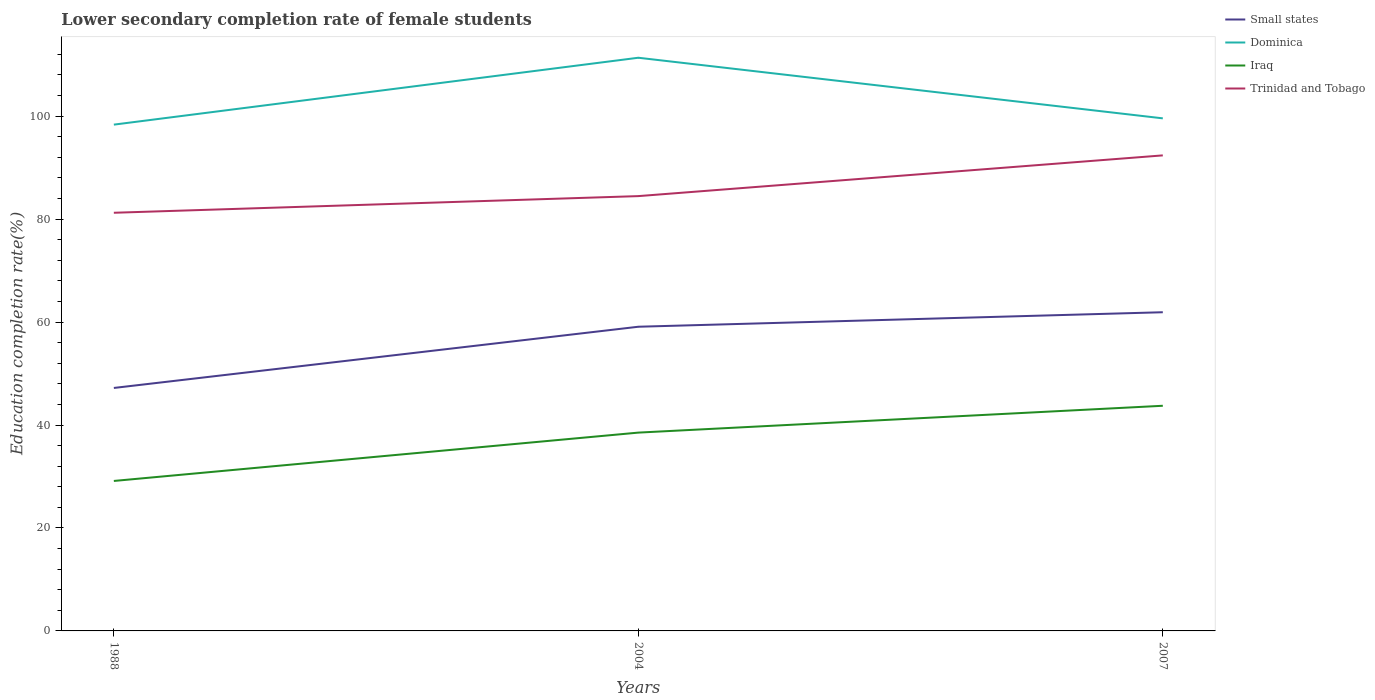How many different coloured lines are there?
Provide a short and direct response. 4. Is the number of lines equal to the number of legend labels?
Your response must be concise. Yes. Across all years, what is the maximum lower secondary completion rate of female students in Small states?
Provide a succinct answer. 47.2. In which year was the lower secondary completion rate of female students in Iraq maximum?
Offer a terse response. 1988. What is the total lower secondary completion rate of female students in Dominica in the graph?
Ensure brevity in your answer.  11.78. What is the difference between the highest and the second highest lower secondary completion rate of female students in Dominica?
Keep it short and to the point. 13. Is the lower secondary completion rate of female students in Iraq strictly greater than the lower secondary completion rate of female students in Trinidad and Tobago over the years?
Your response must be concise. Yes. What is the difference between two consecutive major ticks on the Y-axis?
Your answer should be compact. 20. Are the values on the major ticks of Y-axis written in scientific E-notation?
Offer a terse response. No. Does the graph contain any zero values?
Your answer should be compact. No. Does the graph contain grids?
Keep it short and to the point. No. Where does the legend appear in the graph?
Provide a short and direct response. Top right. How many legend labels are there?
Your response must be concise. 4. What is the title of the graph?
Offer a very short reply. Lower secondary completion rate of female students. What is the label or title of the X-axis?
Your answer should be very brief. Years. What is the label or title of the Y-axis?
Offer a very short reply. Education completion rate(%). What is the Education completion rate(%) in Small states in 1988?
Make the answer very short. 47.2. What is the Education completion rate(%) in Dominica in 1988?
Make the answer very short. 98.36. What is the Education completion rate(%) of Iraq in 1988?
Provide a succinct answer. 29.13. What is the Education completion rate(%) of Trinidad and Tobago in 1988?
Your answer should be very brief. 81.24. What is the Education completion rate(%) of Small states in 2004?
Give a very brief answer. 59.09. What is the Education completion rate(%) of Dominica in 2004?
Provide a short and direct response. 111.35. What is the Education completion rate(%) of Iraq in 2004?
Provide a succinct answer. 38.53. What is the Education completion rate(%) in Trinidad and Tobago in 2004?
Your response must be concise. 84.47. What is the Education completion rate(%) of Small states in 2007?
Your answer should be very brief. 61.91. What is the Education completion rate(%) of Dominica in 2007?
Offer a very short reply. 99.58. What is the Education completion rate(%) in Iraq in 2007?
Provide a succinct answer. 43.74. What is the Education completion rate(%) of Trinidad and Tobago in 2007?
Provide a short and direct response. 92.38. Across all years, what is the maximum Education completion rate(%) of Small states?
Provide a succinct answer. 61.91. Across all years, what is the maximum Education completion rate(%) of Dominica?
Provide a short and direct response. 111.35. Across all years, what is the maximum Education completion rate(%) in Iraq?
Offer a very short reply. 43.74. Across all years, what is the maximum Education completion rate(%) of Trinidad and Tobago?
Provide a short and direct response. 92.38. Across all years, what is the minimum Education completion rate(%) in Small states?
Offer a terse response. 47.2. Across all years, what is the minimum Education completion rate(%) in Dominica?
Offer a terse response. 98.36. Across all years, what is the minimum Education completion rate(%) in Iraq?
Keep it short and to the point. 29.13. Across all years, what is the minimum Education completion rate(%) in Trinidad and Tobago?
Make the answer very short. 81.24. What is the total Education completion rate(%) of Small states in the graph?
Your answer should be very brief. 168.21. What is the total Education completion rate(%) in Dominica in the graph?
Ensure brevity in your answer.  309.29. What is the total Education completion rate(%) in Iraq in the graph?
Keep it short and to the point. 111.4. What is the total Education completion rate(%) of Trinidad and Tobago in the graph?
Keep it short and to the point. 258.09. What is the difference between the Education completion rate(%) of Small states in 1988 and that in 2004?
Ensure brevity in your answer.  -11.89. What is the difference between the Education completion rate(%) of Dominica in 1988 and that in 2004?
Keep it short and to the point. -13. What is the difference between the Education completion rate(%) in Iraq in 1988 and that in 2004?
Your answer should be very brief. -9.39. What is the difference between the Education completion rate(%) in Trinidad and Tobago in 1988 and that in 2004?
Your answer should be very brief. -3.24. What is the difference between the Education completion rate(%) in Small states in 1988 and that in 2007?
Your response must be concise. -14.71. What is the difference between the Education completion rate(%) in Dominica in 1988 and that in 2007?
Provide a succinct answer. -1.22. What is the difference between the Education completion rate(%) of Iraq in 1988 and that in 2007?
Ensure brevity in your answer.  -14.61. What is the difference between the Education completion rate(%) of Trinidad and Tobago in 1988 and that in 2007?
Provide a short and direct response. -11.15. What is the difference between the Education completion rate(%) of Small states in 2004 and that in 2007?
Your answer should be very brief. -2.82. What is the difference between the Education completion rate(%) in Dominica in 2004 and that in 2007?
Provide a short and direct response. 11.78. What is the difference between the Education completion rate(%) in Iraq in 2004 and that in 2007?
Provide a short and direct response. -5.22. What is the difference between the Education completion rate(%) of Trinidad and Tobago in 2004 and that in 2007?
Give a very brief answer. -7.91. What is the difference between the Education completion rate(%) in Small states in 1988 and the Education completion rate(%) in Dominica in 2004?
Give a very brief answer. -64.15. What is the difference between the Education completion rate(%) of Small states in 1988 and the Education completion rate(%) of Iraq in 2004?
Your answer should be very brief. 8.67. What is the difference between the Education completion rate(%) in Small states in 1988 and the Education completion rate(%) in Trinidad and Tobago in 2004?
Provide a short and direct response. -37.27. What is the difference between the Education completion rate(%) in Dominica in 1988 and the Education completion rate(%) in Iraq in 2004?
Make the answer very short. 59.83. What is the difference between the Education completion rate(%) of Dominica in 1988 and the Education completion rate(%) of Trinidad and Tobago in 2004?
Keep it short and to the point. 13.89. What is the difference between the Education completion rate(%) of Iraq in 1988 and the Education completion rate(%) of Trinidad and Tobago in 2004?
Provide a succinct answer. -55.34. What is the difference between the Education completion rate(%) in Small states in 1988 and the Education completion rate(%) in Dominica in 2007?
Keep it short and to the point. -52.37. What is the difference between the Education completion rate(%) of Small states in 1988 and the Education completion rate(%) of Iraq in 2007?
Give a very brief answer. 3.46. What is the difference between the Education completion rate(%) in Small states in 1988 and the Education completion rate(%) in Trinidad and Tobago in 2007?
Give a very brief answer. -45.18. What is the difference between the Education completion rate(%) of Dominica in 1988 and the Education completion rate(%) of Iraq in 2007?
Your answer should be compact. 54.61. What is the difference between the Education completion rate(%) of Dominica in 1988 and the Education completion rate(%) of Trinidad and Tobago in 2007?
Offer a very short reply. 5.97. What is the difference between the Education completion rate(%) in Iraq in 1988 and the Education completion rate(%) in Trinidad and Tobago in 2007?
Offer a very short reply. -63.25. What is the difference between the Education completion rate(%) in Small states in 2004 and the Education completion rate(%) in Dominica in 2007?
Your response must be concise. -40.48. What is the difference between the Education completion rate(%) in Small states in 2004 and the Education completion rate(%) in Iraq in 2007?
Provide a succinct answer. 15.35. What is the difference between the Education completion rate(%) in Small states in 2004 and the Education completion rate(%) in Trinidad and Tobago in 2007?
Provide a succinct answer. -33.29. What is the difference between the Education completion rate(%) of Dominica in 2004 and the Education completion rate(%) of Iraq in 2007?
Ensure brevity in your answer.  67.61. What is the difference between the Education completion rate(%) of Dominica in 2004 and the Education completion rate(%) of Trinidad and Tobago in 2007?
Keep it short and to the point. 18.97. What is the difference between the Education completion rate(%) of Iraq in 2004 and the Education completion rate(%) of Trinidad and Tobago in 2007?
Give a very brief answer. -53.86. What is the average Education completion rate(%) in Small states per year?
Offer a terse response. 56.07. What is the average Education completion rate(%) of Dominica per year?
Offer a very short reply. 103.1. What is the average Education completion rate(%) of Iraq per year?
Provide a short and direct response. 37.13. What is the average Education completion rate(%) in Trinidad and Tobago per year?
Your answer should be compact. 86.03. In the year 1988, what is the difference between the Education completion rate(%) of Small states and Education completion rate(%) of Dominica?
Provide a succinct answer. -51.15. In the year 1988, what is the difference between the Education completion rate(%) in Small states and Education completion rate(%) in Iraq?
Provide a short and direct response. 18.07. In the year 1988, what is the difference between the Education completion rate(%) of Small states and Education completion rate(%) of Trinidad and Tobago?
Keep it short and to the point. -34.03. In the year 1988, what is the difference between the Education completion rate(%) in Dominica and Education completion rate(%) in Iraq?
Make the answer very short. 69.22. In the year 1988, what is the difference between the Education completion rate(%) in Dominica and Education completion rate(%) in Trinidad and Tobago?
Your response must be concise. 17.12. In the year 1988, what is the difference between the Education completion rate(%) of Iraq and Education completion rate(%) of Trinidad and Tobago?
Provide a short and direct response. -52.1. In the year 2004, what is the difference between the Education completion rate(%) of Small states and Education completion rate(%) of Dominica?
Your response must be concise. -52.26. In the year 2004, what is the difference between the Education completion rate(%) of Small states and Education completion rate(%) of Iraq?
Keep it short and to the point. 20.57. In the year 2004, what is the difference between the Education completion rate(%) in Small states and Education completion rate(%) in Trinidad and Tobago?
Your answer should be very brief. -25.38. In the year 2004, what is the difference between the Education completion rate(%) of Dominica and Education completion rate(%) of Iraq?
Provide a succinct answer. 72.83. In the year 2004, what is the difference between the Education completion rate(%) of Dominica and Education completion rate(%) of Trinidad and Tobago?
Your answer should be compact. 26.88. In the year 2004, what is the difference between the Education completion rate(%) in Iraq and Education completion rate(%) in Trinidad and Tobago?
Your answer should be compact. -45.94. In the year 2007, what is the difference between the Education completion rate(%) of Small states and Education completion rate(%) of Dominica?
Your response must be concise. -37.67. In the year 2007, what is the difference between the Education completion rate(%) of Small states and Education completion rate(%) of Iraq?
Provide a short and direct response. 18.17. In the year 2007, what is the difference between the Education completion rate(%) in Small states and Education completion rate(%) in Trinidad and Tobago?
Your answer should be compact. -30.47. In the year 2007, what is the difference between the Education completion rate(%) of Dominica and Education completion rate(%) of Iraq?
Offer a terse response. 55.83. In the year 2007, what is the difference between the Education completion rate(%) of Dominica and Education completion rate(%) of Trinidad and Tobago?
Offer a terse response. 7.19. In the year 2007, what is the difference between the Education completion rate(%) in Iraq and Education completion rate(%) in Trinidad and Tobago?
Keep it short and to the point. -48.64. What is the ratio of the Education completion rate(%) of Small states in 1988 to that in 2004?
Your answer should be compact. 0.8. What is the ratio of the Education completion rate(%) of Dominica in 1988 to that in 2004?
Provide a succinct answer. 0.88. What is the ratio of the Education completion rate(%) of Iraq in 1988 to that in 2004?
Your answer should be very brief. 0.76. What is the ratio of the Education completion rate(%) in Trinidad and Tobago in 1988 to that in 2004?
Your response must be concise. 0.96. What is the ratio of the Education completion rate(%) in Small states in 1988 to that in 2007?
Your answer should be compact. 0.76. What is the ratio of the Education completion rate(%) in Iraq in 1988 to that in 2007?
Provide a short and direct response. 0.67. What is the ratio of the Education completion rate(%) in Trinidad and Tobago in 1988 to that in 2007?
Your response must be concise. 0.88. What is the ratio of the Education completion rate(%) in Small states in 2004 to that in 2007?
Your answer should be compact. 0.95. What is the ratio of the Education completion rate(%) in Dominica in 2004 to that in 2007?
Provide a short and direct response. 1.12. What is the ratio of the Education completion rate(%) of Iraq in 2004 to that in 2007?
Keep it short and to the point. 0.88. What is the ratio of the Education completion rate(%) of Trinidad and Tobago in 2004 to that in 2007?
Make the answer very short. 0.91. What is the difference between the highest and the second highest Education completion rate(%) of Small states?
Ensure brevity in your answer.  2.82. What is the difference between the highest and the second highest Education completion rate(%) in Dominica?
Give a very brief answer. 11.78. What is the difference between the highest and the second highest Education completion rate(%) in Iraq?
Keep it short and to the point. 5.22. What is the difference between the highest and the second highest Education completion rate(%) in Trinidad and Tobago?
Your response must be concise. 7.91. What is the difference between the highest and the lowest Education completion rate(%) of Small states?
Provide a succinct answer. 14.71. What is the difference between the highest and the lowest Education completion rate(%) of Dominica?
Give a very brief answer. 13. What is the difference between the highest and the lowest Education completion rate(%) of Iraq?
Your response must be concise. 14.61. What is the difference between the highest and the lowest Education completion rate(%) of Trinidad and Tobago?
Provide a short and direct response. 11.15. 